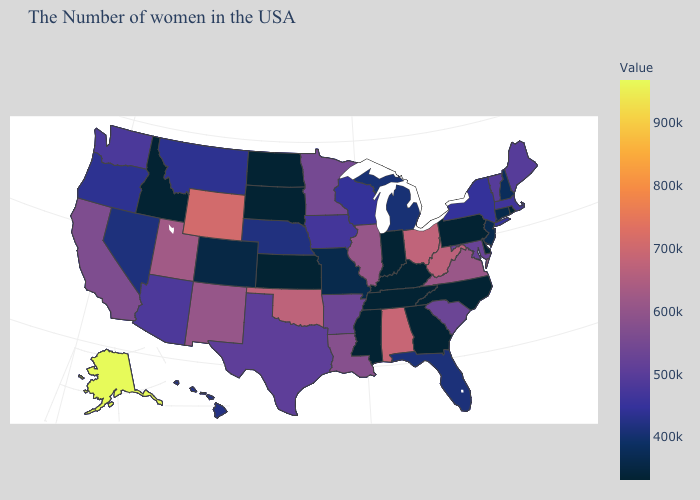Does Florida have a higher value than Idaho?
Quick response, please. Yes. Does New Hampshire have the highest value in the Northeast?
Be succinct. No. Among the states that border Georgia , which have the highest value?
Keep it brief. Alabama. Among the states that border Indiana , does Kentucky have the highest value?
Short answer required. No. Among the states that border New Jersey , which have the highest value?
Concise answer only. New York. 